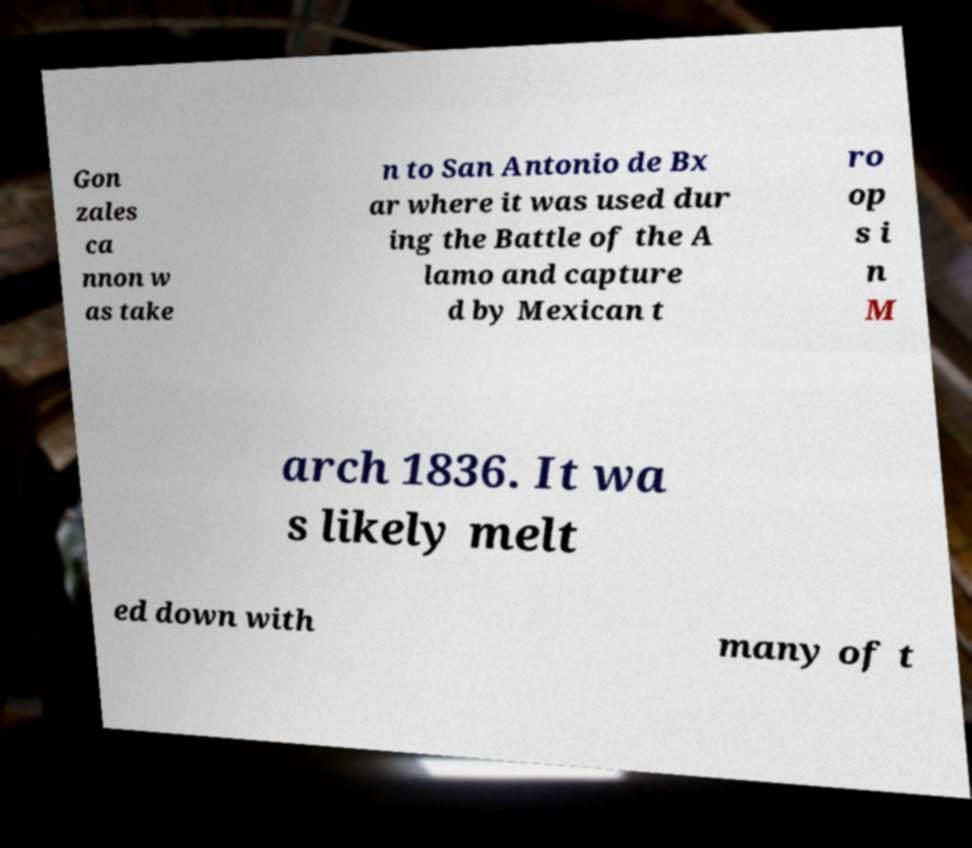Could you assist in decoding the text presented in this image and type it out clearly? Gon zales ca nnon w as take n to San Antonio de Bx ar where it was used dur ing the Battle of the A lamo and capture d by Mexican t ro op s i n M arch 1836. It wa s likely melt ed down with many of t 